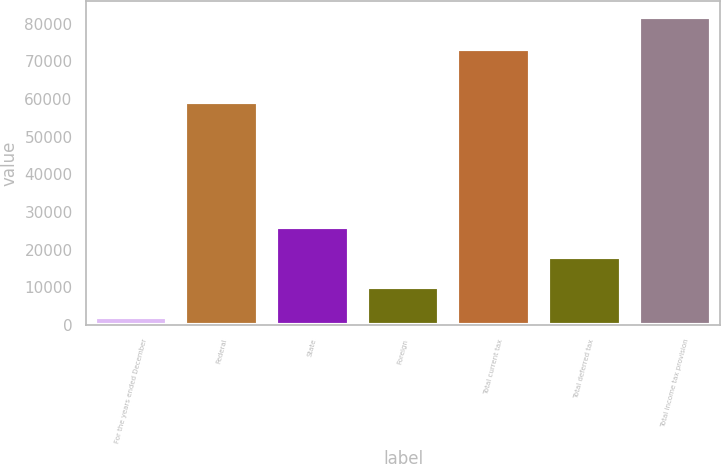Convert chart. <chart><loc_0><loc_0><loc_500><loc_500><bar_chart><fcel>For the years ended December<fcel>Federal<fcel>State<fcel>Foreign<fcel>Total current tax<fcel>Total deferred tax<fcel>Total income tax provision<nl><fcel>2014<fcel>59053<fcel>25955.8<fcel>9994.6<fcel>73380<fcel>17975.2<fcel>81820<nl></chart> 